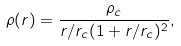<formula> <loc_0><loc_0><loc_500><loc_500>\rho ( r ) = \frac { \rho _ { c } } { r / r _ { c } ( 1 + r / r _ { c } ) ^ { 2 } } ,</formula> 